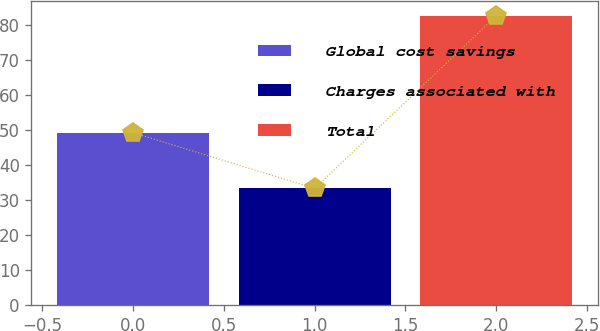<chart> <loc_0><loc_0><loc_500><loc_500><bar_chart><fcel>Global cost savings<fcel>Charges associated with<fcel>Total<nl><fcel>49.3<fcel>33.4<fcel>82.7<nl></chart> 